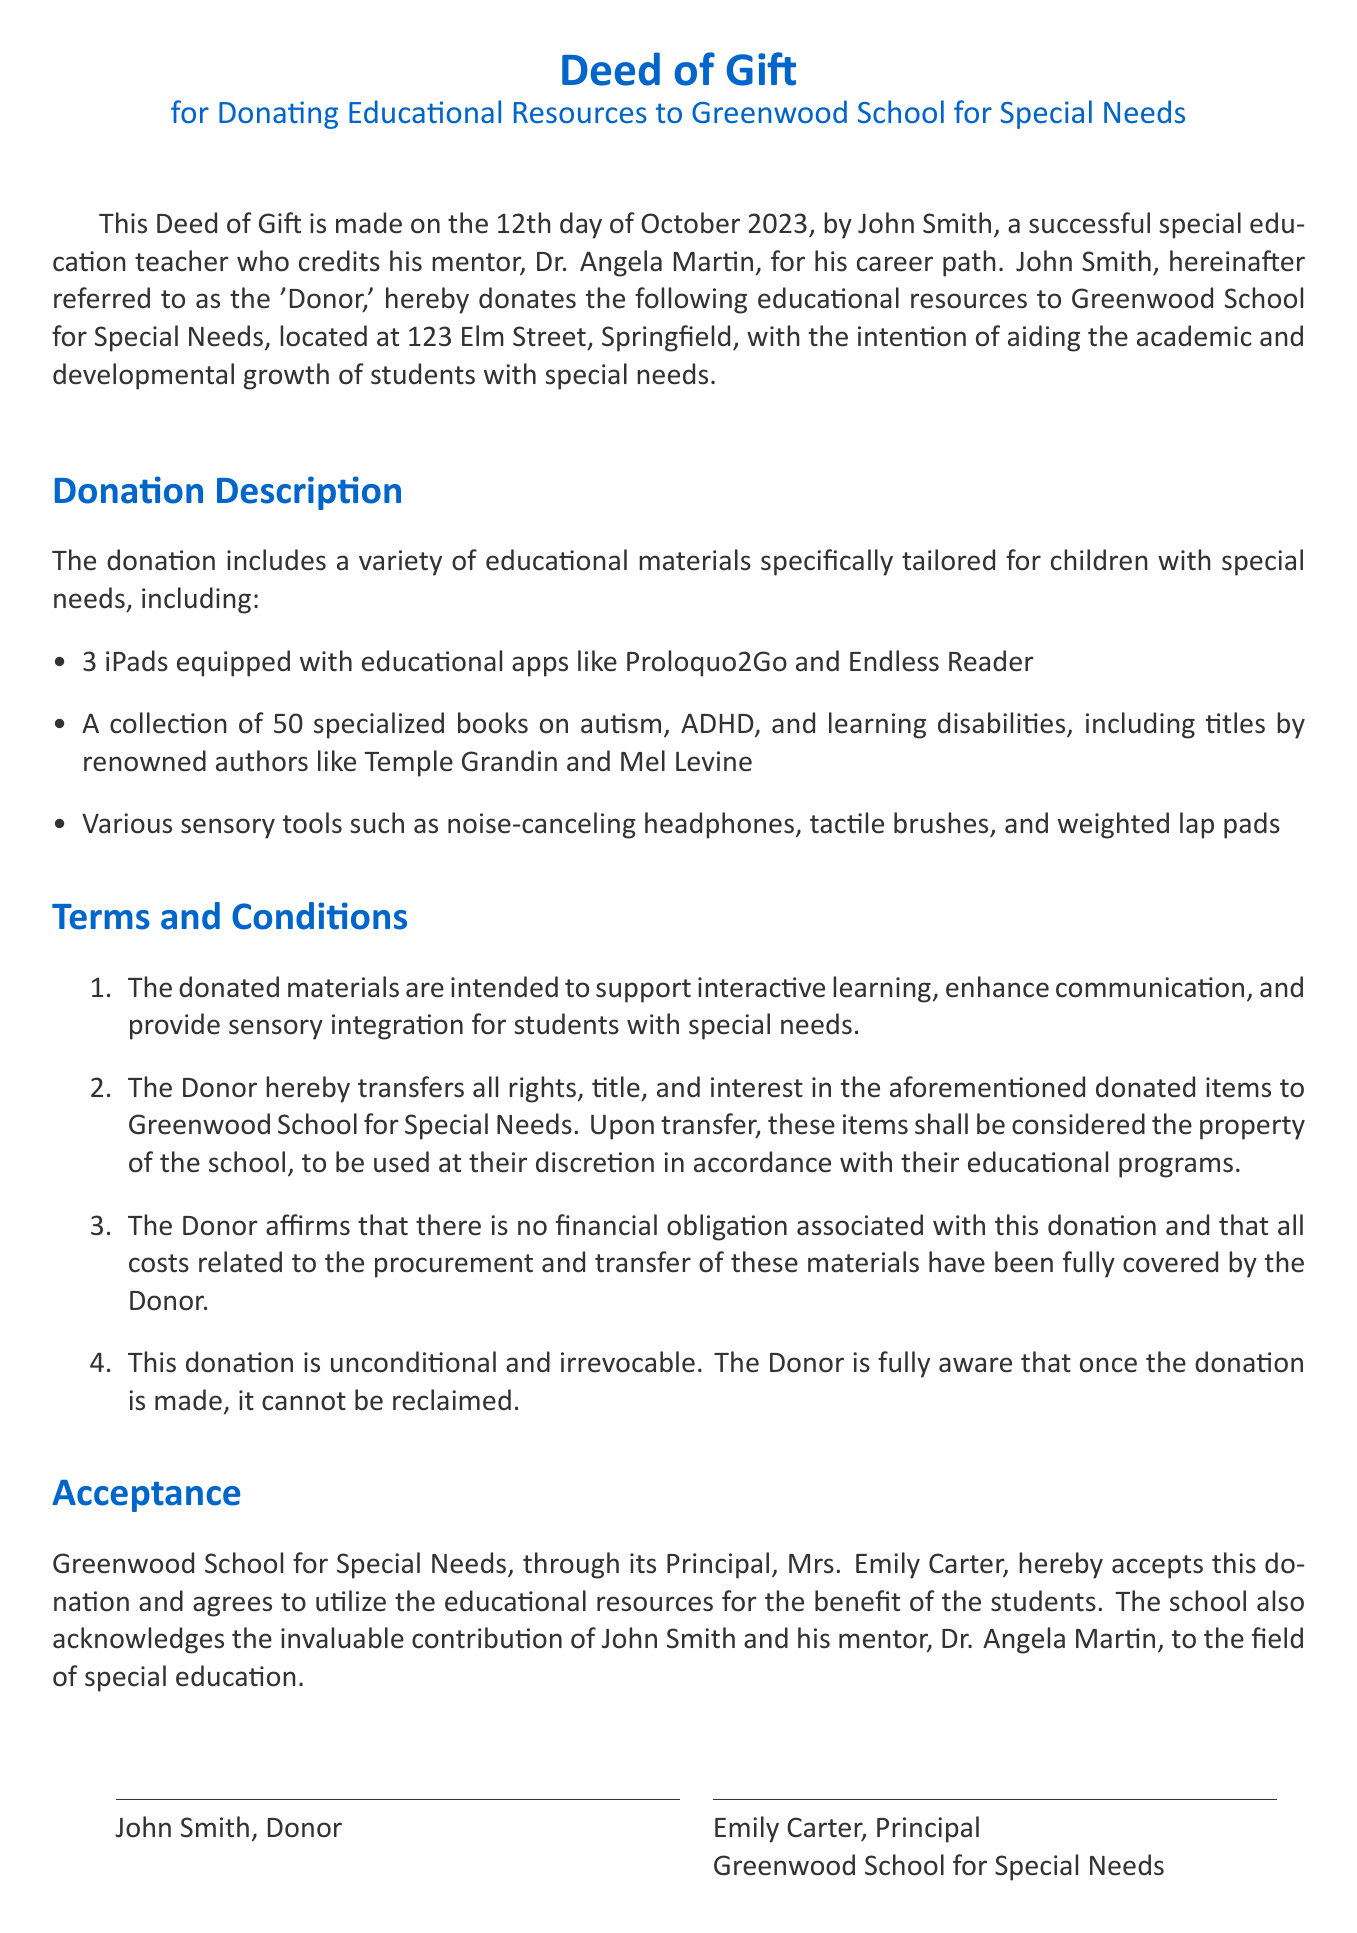What is the date of the Deed of Gift? The date of the Deed of Gift is stated in the opening paragraph.
Answer: 12th day of October 2023 Who is the Donor? The Donor is the individual who is making the donation as introduced in the document.
Answer: John Smith How many iPads are included in the donation? The number of iPads is specifically listed in the donation description section.
Answer: 3 What position does Emily Carter hold? Emily Carter is mentioned in the acceptance section of the deed.
Answer: Principal What type of educational materials are included? The donation description provides a general category of the materials.
Answer: Educational resources What is the purpose of the donation? The intended purpose of the donation is elaborated upon in the terms and conditions section.
Answer: Aid academic and developmental growth Is the donation revocable? The document specifies the nature of the donation in terms and conditions.
Answer: No What is the name of the school receiving the donation? The name of the school is mentioned at the top of the document.
Answer: Greenwood School for Special Needs 